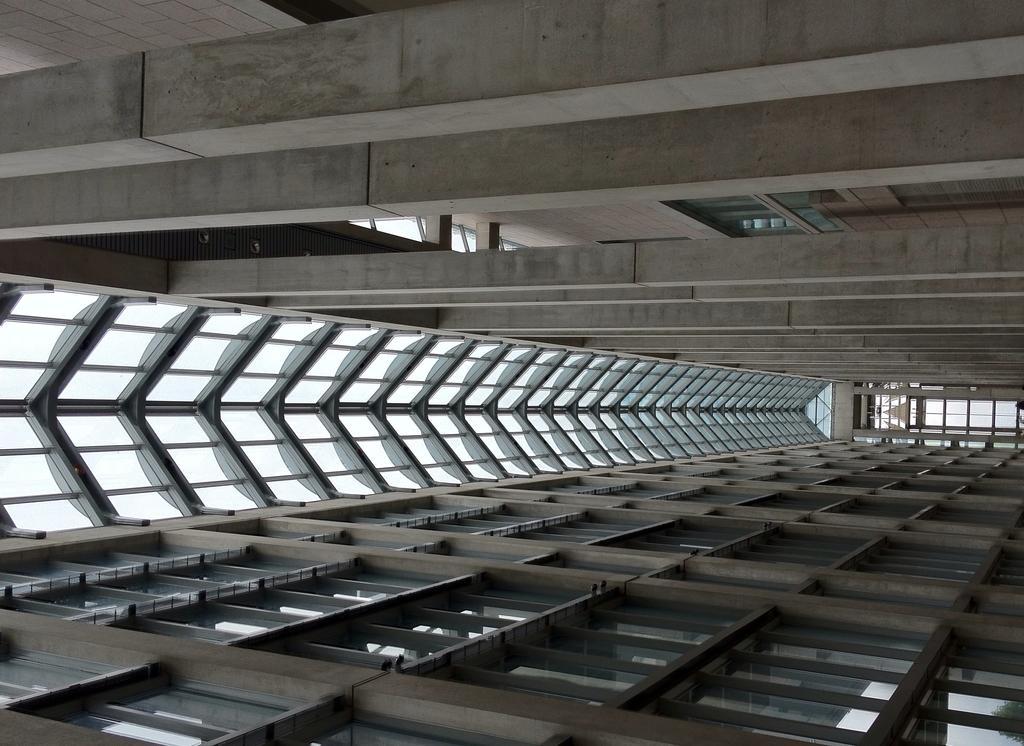Can you describe this image briefly? In this picture there is a metal roof in the center of the image. 